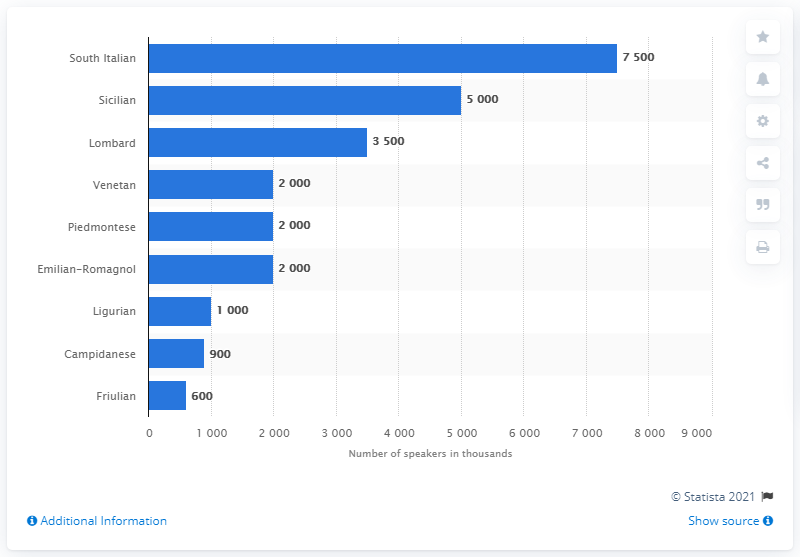List a handful of essential elements in this visual. The most commonly spoken dialect in Italy is South Italian. 